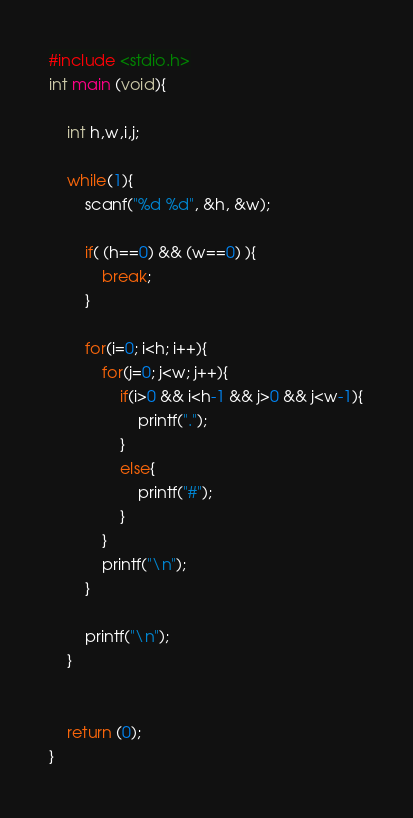<code> <loc_0><loc_0><loc_500><loc_500><_C_>#include <stdio.h>
int main (void){
    
    int h,w,i,j;
    
    while(1){
        scanf("%d %d", &h, &w);
        
        if( (h==0) && (w==0) ){
            break;
        }
        
        for(i=0; i<h; i++){
            for(j=0; j<w; j++){
                if(i>0 && i<h-1 && j>0 && j<w-1){
                    printf(".");
                }
                else{
                    printf("#");
                }
            }
            printf("\n");
        }
        
        printf("\n");
    }
    
    
    return (0);
}</code> 